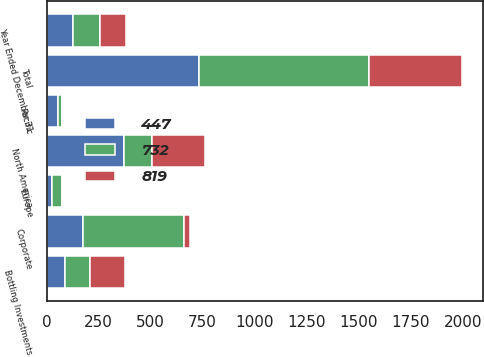Convert chart to OTSL. <chart><loc_0><loc_0><loc_500><loc_500><stacked_bar_chart><ecel><fcel>Year Ended December 31<fcel>Europe<fcel>North America<fcel>Pacific<fcel>Bottling Investments<fcel>Corporate<fcel>Total<nl><fcel>819<fcel>127.5<fcel>3<fcel>255<fcel>1<fcel>164<fcel>30<fcel>447<nl><fcel>447<fcel>127.5<fcel>25<fcel>374<fcel>54<fcel>89<fcel>174<fcel>732<nl><fcel>732<fcel>127.5<fcel>50<fcel>133<fcel>22<fcel>122<fcel>485<fcel>819<nl></chart> 